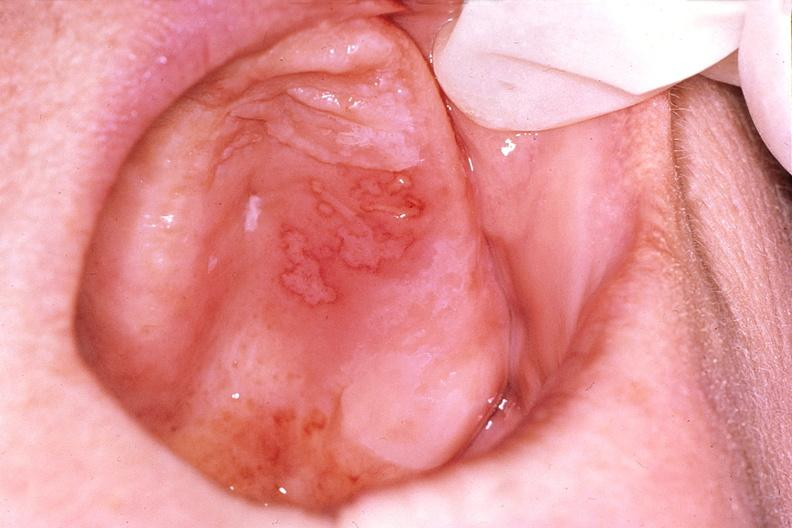does endometritis postpartum show mouth, herpes, ulcers?
Answer the question using a single word or phrase. No 